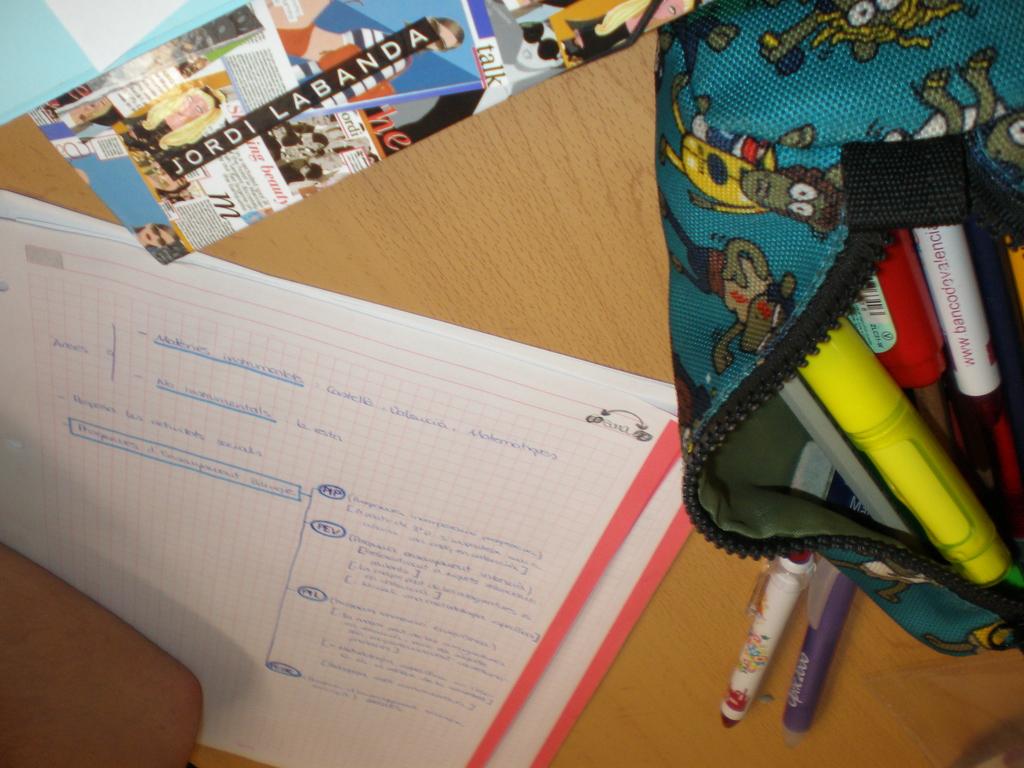What does the card on top say?
Your answer should be very brief. Jordi labanda. 